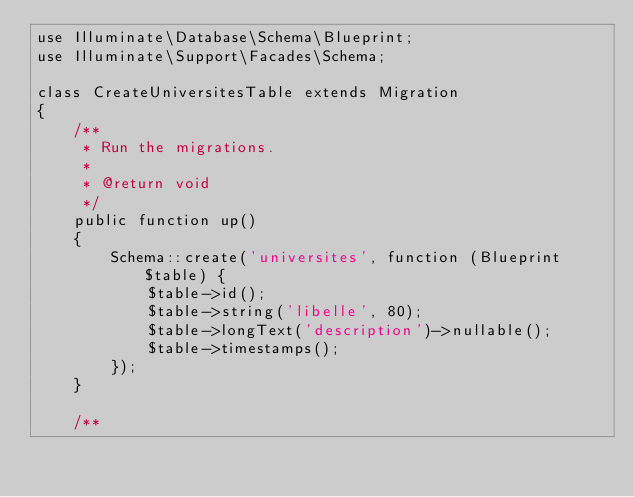<code> <loc_0><loc_0><loc_500><loc_500><_PHP_>use Illuminate\Database\Schema\Blueprint;
use Illuminate\Support\Facades\Schema;

class CreateUniversitesTable extends Migration
{
    /**
     * Run the migrations.
     *
     * @return void
     */
    public function up()
    {
        Schema::create('universites', function (Blueprint $table) {
            $table->id();
            $table->string('libelle', 80);
            $table->longText('description')->nullable();
            $table->timestamps();
        });
    }

    /**</code> 